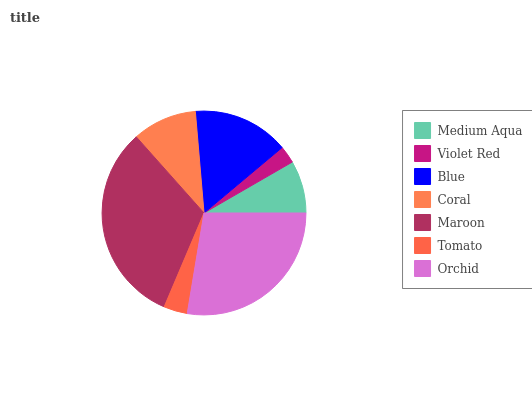Is Violet Red the minimum?
Answer yes or no. Yes. Is Maroon the maximum?
Answer yes or no. Yes. Is Blue the minimum?
Answer yes or no. No. Is Blue the maximum?
Answer yes or no. No. Is Blue greater than Violet Red?
Answer yes or no. Yes. Is Violet Red less than Blue?
Answer yes or no. Yes. Is Violet Red greater than Blue?
Answer yes or no. No. Is Blue less than Violet Red?
Answer yes or no. No. Is Coral the high median?
Answer yes or no. Yes. Is Coral the low median?
Answer yes or no. Yes. Is Medium Aqua the high median?
Answer yes or no. No. Is Blue the low median?
Answer yes or no. No. 